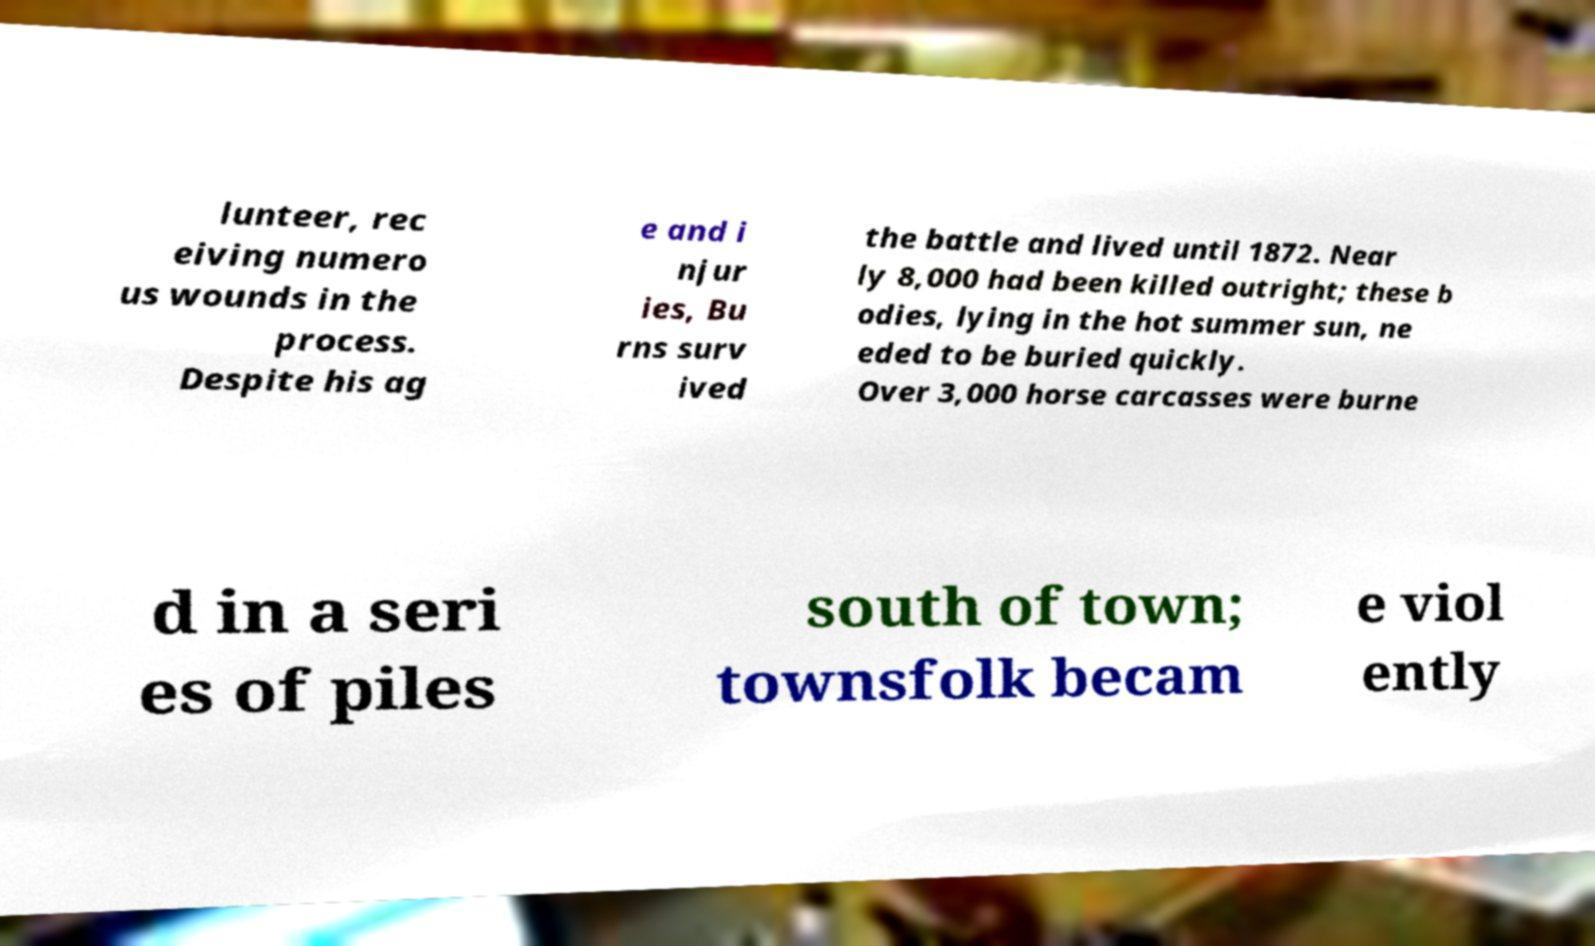Can you accurately transcribe the text from the provided image for me? lunteer, rec eiving numero us wounds in the process. Despite his ag e and i njur ies, Bu rns surv ived the battle and lived until 1872. Near ly 8,000 had been killed outright; these b odies, lying in the hot summer sun, ne eded to be buried quickly. Over 3,000 horse carcasses were burne d in a seri es of piles south of town; townsfolk becam e viol ently 